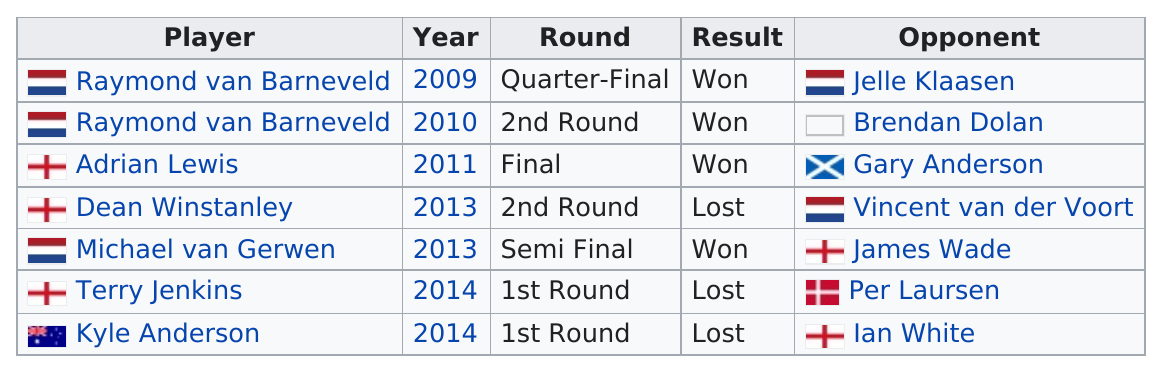Identify some key points in this picture. Raymond van Barneveld won the first World Darts Championship. Other than Kyle Anderson, who lost in 2014 besides Terry Jenkins? It is known that Michael van Gerwen is ranked higher than Terry Jenkins in the table, making him the superior player. Adrian Lewis is the only player who played in 2011, according to the list provided. Dean Winstanley is not listed above or below Kyle Anderson. 